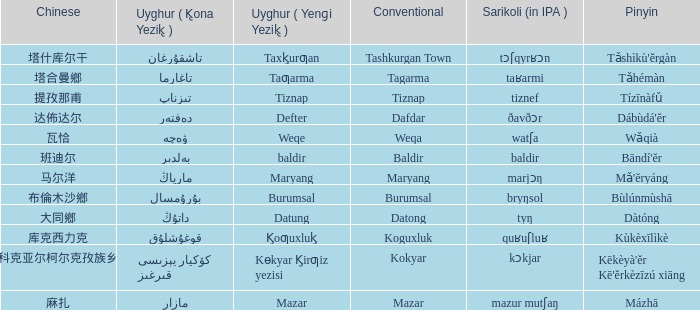Name the pinyin for  kɵkyar k̡irƣiz yezisi Kēkèyà'ěr Kē'ěrkèzīzú xiāng. 